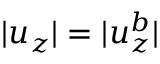Convert formula to latex. <formula><loc_0><loc_0><loc_500><loc_500>| u _ { z } | = | u _ { z } ^ { b } |</formula> 